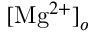<formula> <loc_0><loc_0><loc_500><loc_500>[ M g ^ { 2 + } ] _ { o }</formula> 